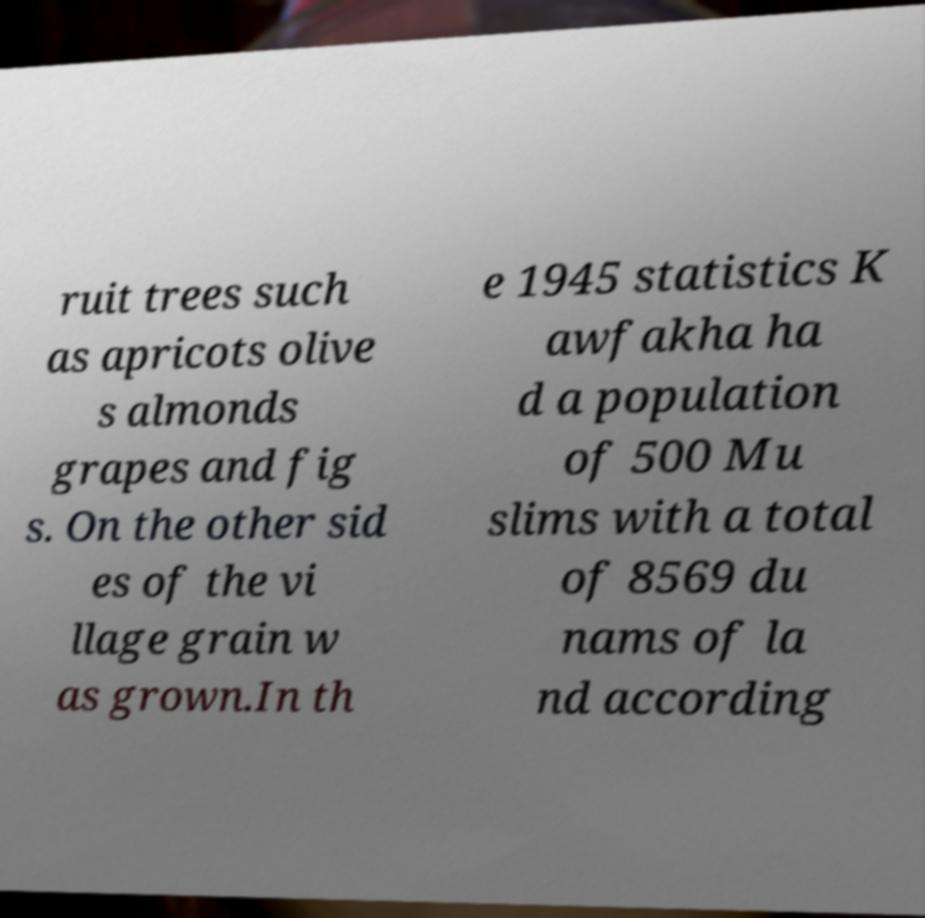Can you accurately transcribe the text from the provided image for me? ruit trees such as apricots olive s almonds grapes and fig s. On the other sid es of the vi llage grain w as grown.In th e 1945 statistics K awfakha ha d a population of 500 Mu slims with a total of 8569 du nams of la nd according 